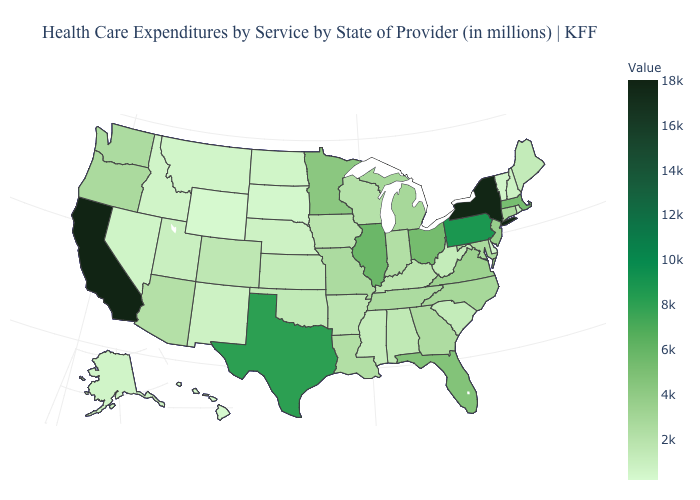Which states have the lowest value in the USA?
Write a very short answer. Hawaii. Does Indiana have the highest value in the MidWest?
Quick response, please. No. Among the states that border Washington , which have the lowest value?
Concise answer only. Idaho. Which states have the lowest value in the USA?
Keep it brief. Hawaii. Does Kentucky have a lower value than Minnesota?
Give a very brief answer. Yes. Which states have the highest value in the USA?
Answer briefly. California. 